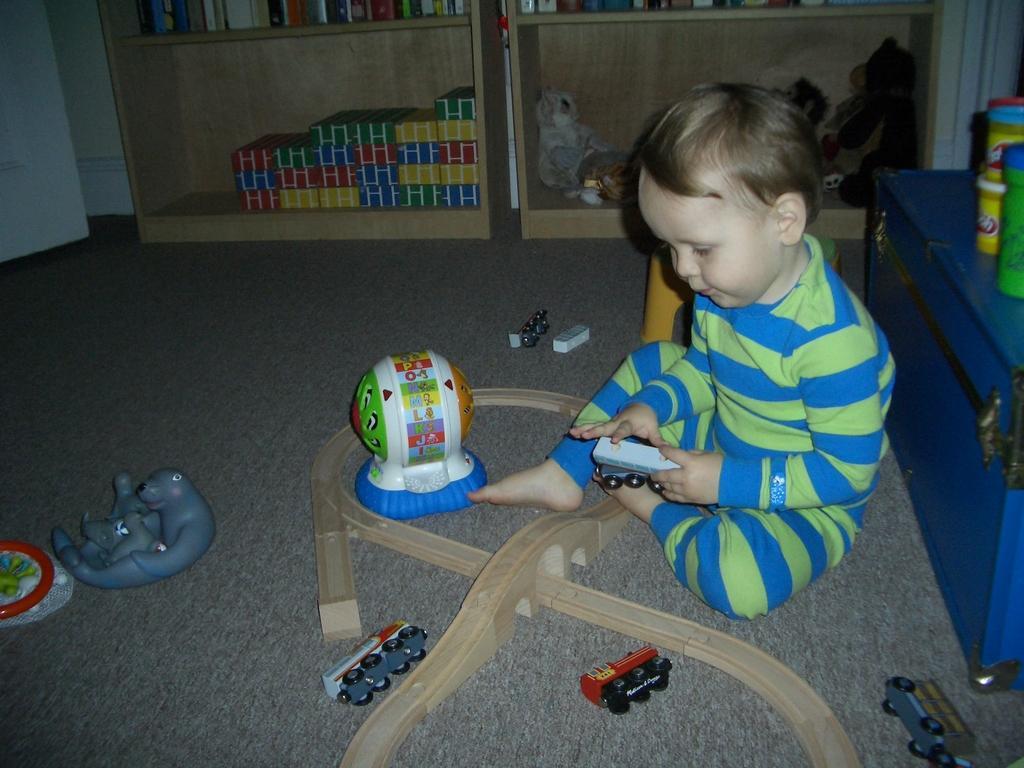How would you summarize this image in a sentence or two? In this picture, there is a kid towards the right. He is wearing strip clothes and he is holding a toy. Before him, there are toys. Behind him, there is a trunk. On the trunks, there are jars. On the top, there are racks with toys and books. In the bottom, there is a mat. 